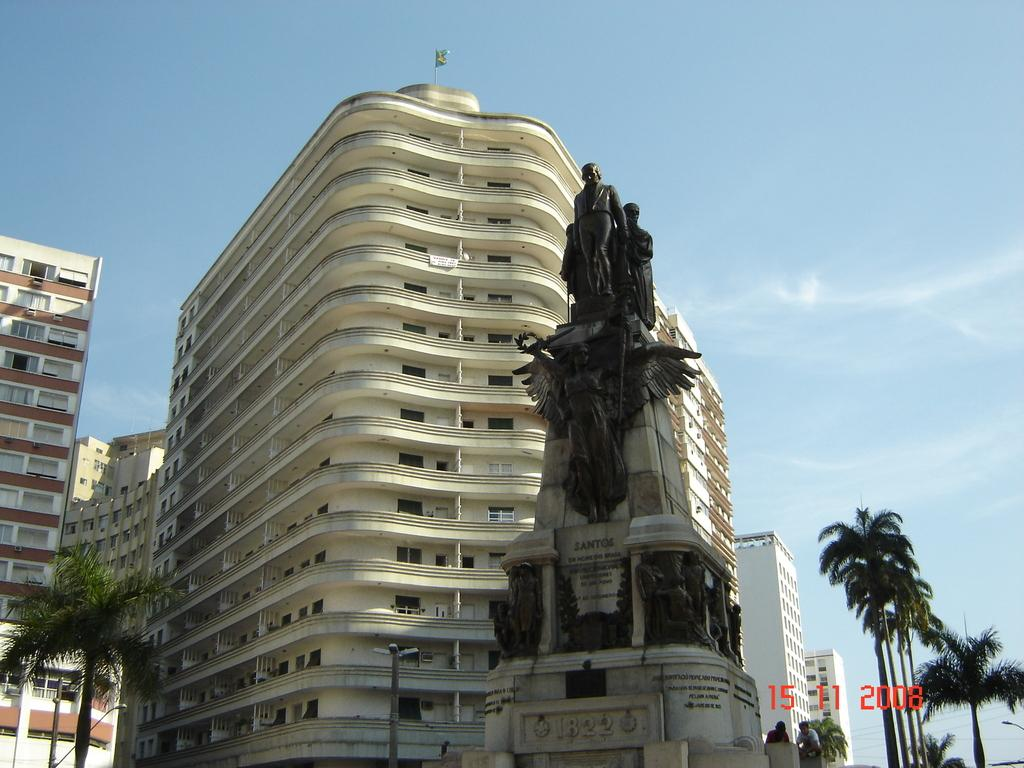<image>
Render a clear and concise summary of the photo. Large statue with the numbers 1822 on it next to a building. 